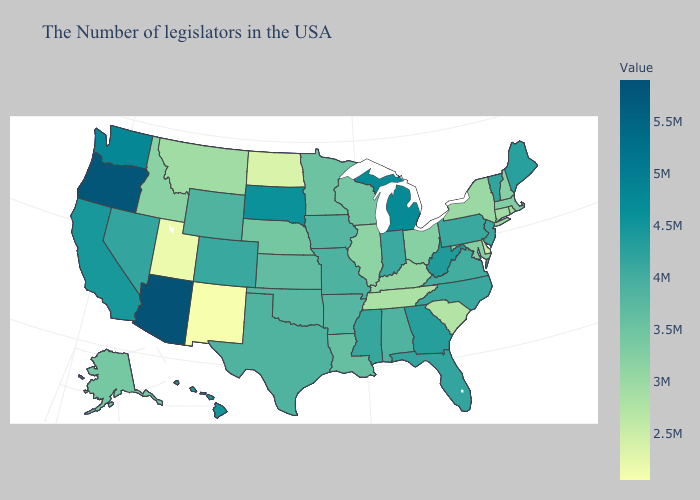Which states have the lowest value in the Northeast?
Be succinct. Rhode Island. Does Arizona have the highest value in the USA?
Quick response, please. Yes. Does Rhode Island have the lowest value in the Northeast?
Give a very brief answer. Yes. Does Arizona have the highest value in the USA?
Give a very brief answer. Yes. Does the map have missing data?
Answer briefly. No. Which states have the highest value in the USA?
Keep it brief. Arizona. Which states hav the highest value in the Northeast?
Concise answer only. Maine. Does the map have missing data?
Write a very short answer. No. 